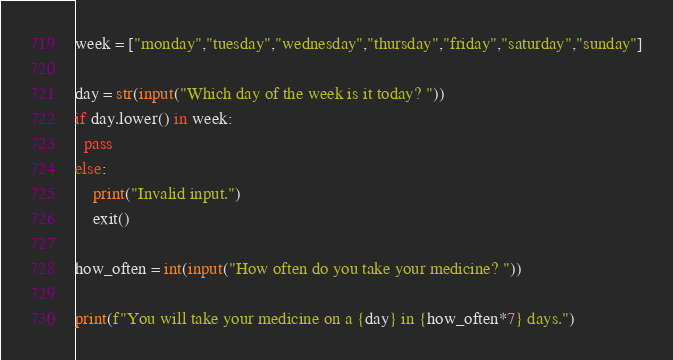Convert code to text. <code><loc_0><loc_0><loc_500><loc_500><_Python_>week = ["monday","tuesday","wednesday","thursday","friday","saturday","sunday"]

day = str(input("Which day of the week is it today? "))
if day.lower() in week:
  pass
else:
    print("Invalid input.")
    exit()

how_often = int(input("How often do you take your medicine? "))

print(f"You will take your medicine on a {day} in {how_often*7} days.")
</code> 